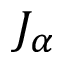<formula> <loc_0><loc_0><loc_500><loc_500>J _ { \alpha }</formula> 